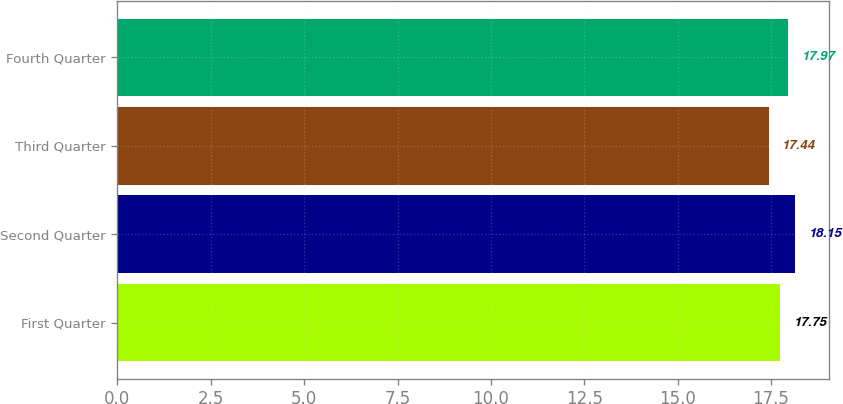Convert chart to OTSL. <chart><loc_0><loc_0><loc_500><loc_500><bar_chart><fcel>First Quarter<fcel>Second Quarter<fcel>Third Quarter<fcel>Fourth Quarter<nl><fcel>17.75<fcel>18.15<fcel>17.44<fcel>17.97<nl></chart> 